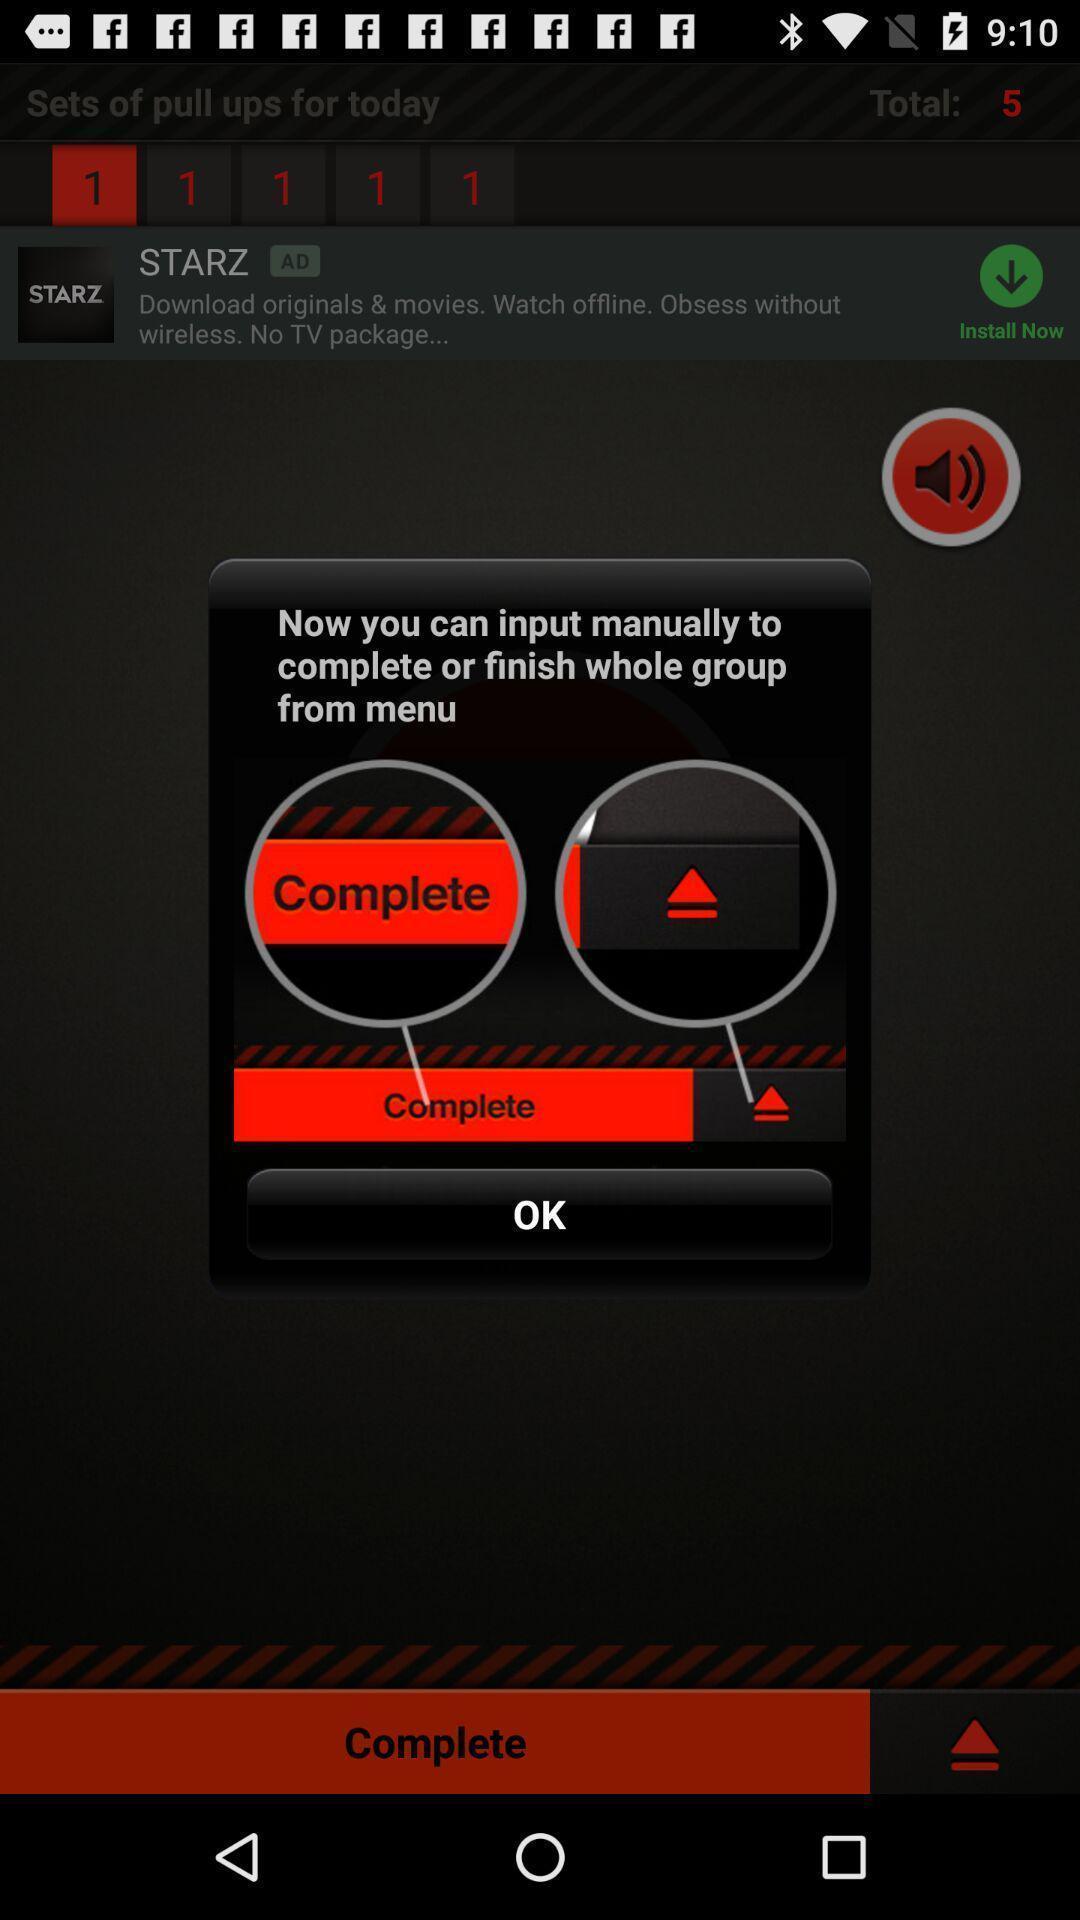What details can you identify in this image? Pop up showing to complete from menu. 